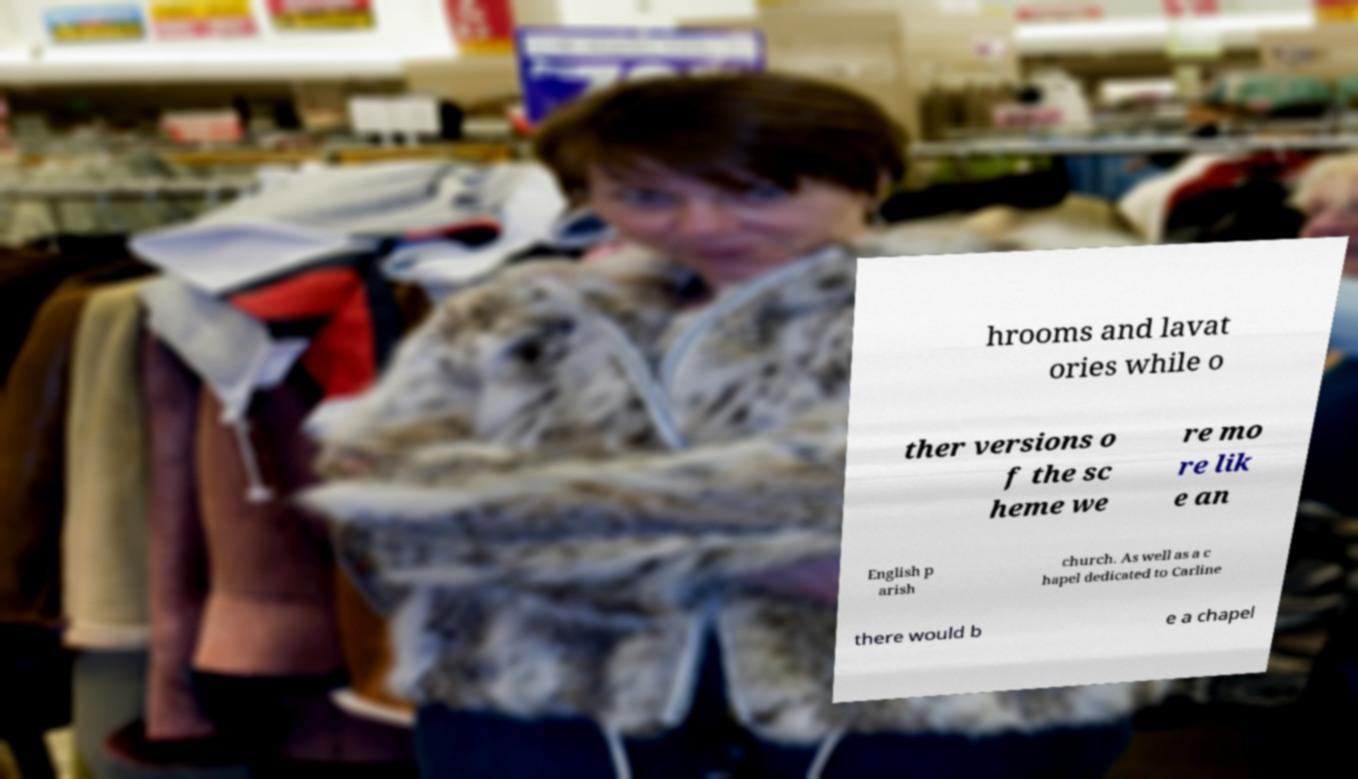For documentation purposes, I need the text within this image transcribed. Could you provide that? hrooms and lavat ories while o ther versions o f the sc heme we re mo re lik e an English p arish church. As well as a c hapel dedicated to Carline there would b e a chapel 